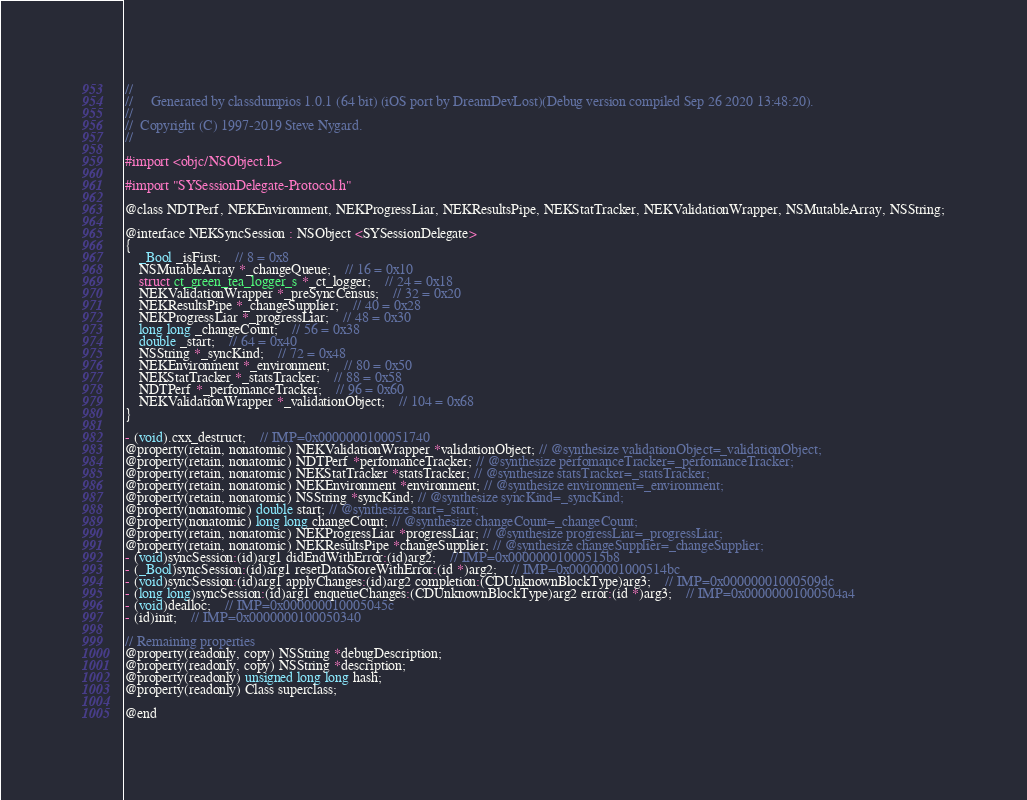Convert code to text. <code><loc_0><loc_0><loc_500><loc_500><_C_>//
//     Generated by classdumpios 1.0.1 (64 bit) (iOS port by DreamDevLost)(Debug version compiled Sep 26 2020 13:48:20).
//
//  Copyright (C) 1997-2019 Steve Nygard.
//

#import <objc/NSObject.h>

#import "SYSessionDelegate-Protocol.h"

@class NDTPerf, NEKEnvironment, NEKProgressLiar, NEKResultsPipe, NEKStatTracker, NEKValidationWrapper, NSMutableArray, NSString;

@interface NEKSyncSession : NSObject <SYSessionDelegate>
{
    _Bool _isFirst;	// 8 = 0x8
    NSMutableArray *_changeQueue;	// 16 = 0x10
    struct ct_green_tea_logger_s *_ct_logger;	// 24 = 0x18
    NEKValidationWrapper *_preSyncCensus;	// 32 = 0x20
    NEKResultsPipe *_changeSupplier;	// 40 = 0x28
    NEKProgressLiar *_progressLiar;	// 48 = 0x30
    long long _changeCount;	// 56 = 0x38
    double _start;	// 64 = 0x40
    NSString *_syncKind;	// 72 = 0x48
    NEKEnvironment *_environment;	// 80 = 0x50
    NEKStatTracker *_statsTracker;	// 88 = 0x58
    NDTPerf *_perfomanceTracker;	// 96 = 0x60
    NEKValidationWrapper *_validationObject;	// 104 = 0x68
}

- (void).cxx_destruct;	// IMP=0x0000000100051740
@property(retain, nonatomic) NEKValidationWrapper *validationObject; // @synthesize validationObject=_validationObject;
@property(retain, nonatomic) NDTPerf *perfomanceTracker; // @synthesize perfomanceTracker=_perfomanceTracker;
@property(retain, nonatomic) NEKStatTracker *statsTracker; // @synthesize statsTracker=_statsTracker;
@property(retain, nonatomic) NEKEnvironment *environment; // @synthesize environment=_environment;
@property(retain, nonatomic) NSString *syncKind; // @synthesize syncKind=_syncKind;
@property(nonatomic) double start; // @synthesize start=_start;
@property(nonatomic) long long changeCount; // @synthesize changeCount=_changeCount;
@property(retain, nonatomic) NEKProgressLiar *progressLiar; // @synthesize progressLiar=_progressLiar;
@property(retain, nonatomic) NEKResultsPipe *changeSupplier; // @synthesize changeSupplier=_changeSupplier;
- (void)syncSession:(id)arg1 didEndWithError:(id)arg2;	// IMP=0x00000001000515b8
- (_Bool)syncSession:(id)arg1 resetDataStoreWithError:(id *)arg2;	// IMP=0x00000001000514bc
- (void)syncSession:(id)arg1 applyChanges:(id)arg2 completion:(CDUnknownBlockType)arg3;	// IMP=0x00000001000509dc
- (long long)syncSession:(id)arg1 enqueueChanges:(CDUnknownBlockType)arg2 error:(id *)arg3;	// IMP=0x00000001000504a4
- (void)dealloc;	// IMP=0x000000010005045c
- (id)init;	// IMP=0x0000000100050340

// Remaining properties
@property(readonly, copy) NSString *debugDescription;
@property(readonly, copy) NSString *description;
@property(readonly) unsigned long long hash;
@property(readonly) Class superclass;

@end

</code> 